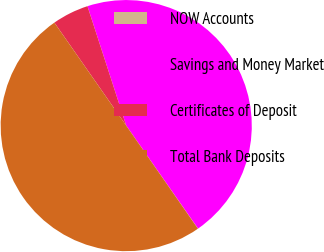<chart> <loc_0><loc_0><loc_500><loc_500><pie_chart><fcel>NOW Accounts<fcel>Savings and Money Market<fcel>Certificates of Deposit<fcel>Total Bank Deposits<nl><fcel>0.02%<fcel>45.3%<fcel>4.7%<fcel>49.98%<nl></chart> 